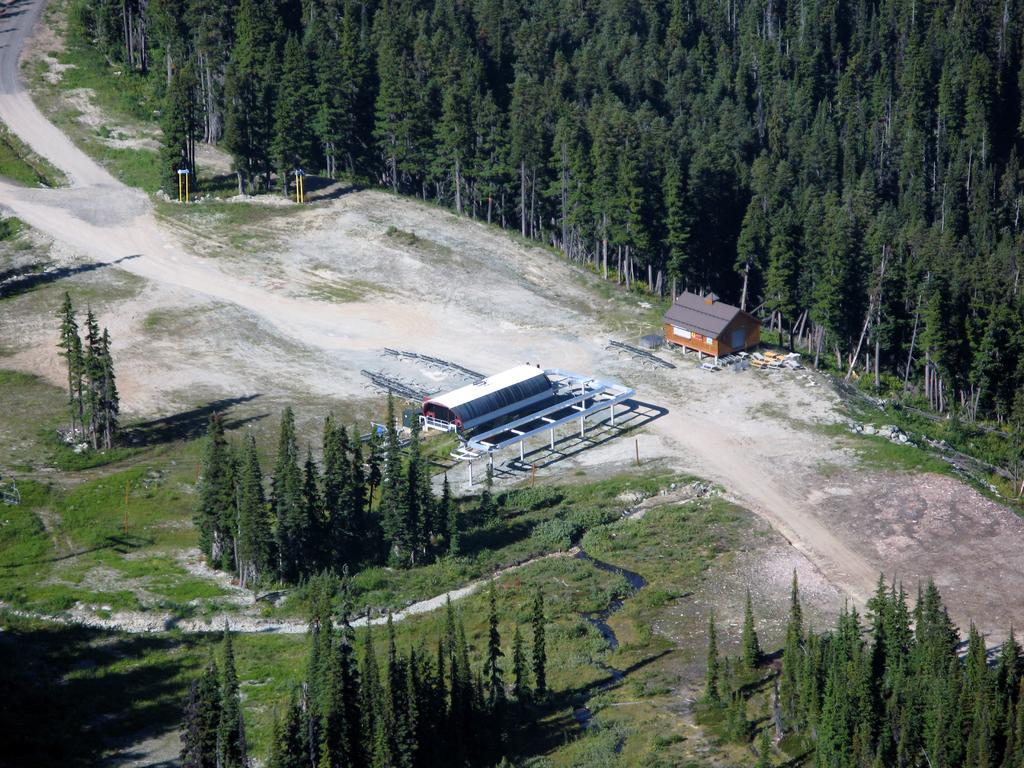What type of surface is visible in the image? There is ground visible in the image. What type of vegetation can be seen on the ground? There is grass in the image. What type of structures are present in the image? There are buildings in the image. What type of trees are present in the image? There are green trees in the image. What type of vertical structures are present in the image? There are poles in the image. What type of pathway is visible in the image? There is a road in the image. What type of lock is used to secure the skate in the image? There is no skate present in the image, so there is no lock to secure it. 